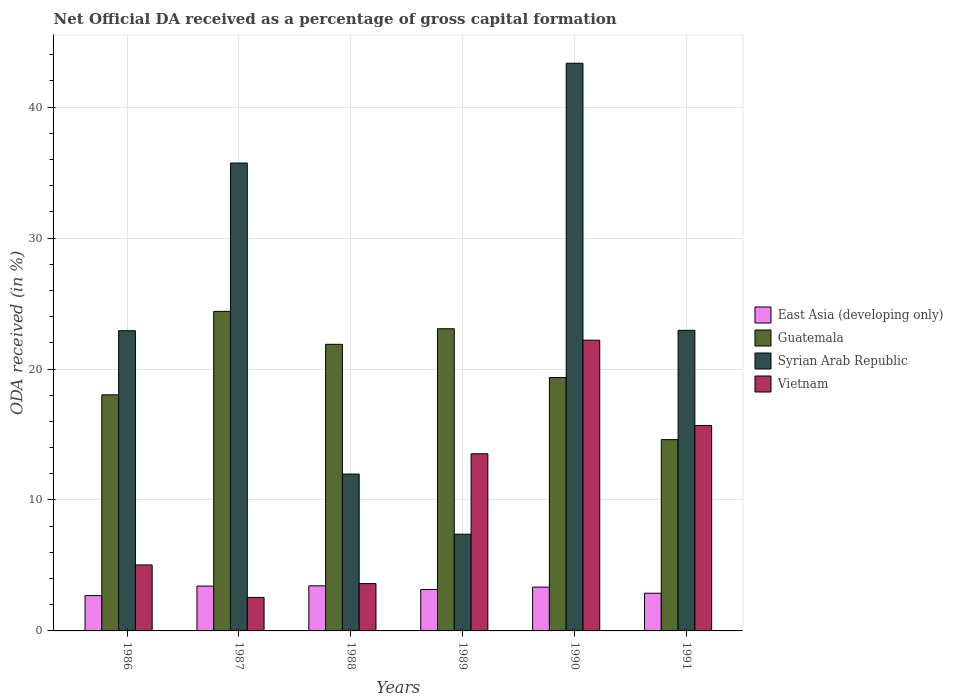How many different coloured bars are there?
Provide a short and direct response. 4. How many bars are there on the 1st tick from the right?
Ensure brevity in your answer.  4. What is the net ODA received in Guatemala in 1986?
Your answer should be compact. 18.03. Across all years, what is the maximum net ODA received in Syrian Arab Republic?
Your answer should be very brief. 43.35. Across all years, what is the minimum net ODA received in Guatemala?
Provide a succinct answer. 14.61. In which year was the net ODA received in Guatemala minimum?
Your response must be concise. 1991. What is the total net ODA received in East Asia (developing only) in the graph?
Offer a very short reply. 18.95. What is the difference between the net ODA received in Syrian Arab Republic in 1986 and that in 1987?
Your answer should be compact. -12.8. What is the difference between the net ODA received in Guatemala in 1986 and the net ODA received in East Asia (developing only) in 1987?
Offer a terse response. 14.61. What is the average net ODA received in Syrian Arab Republic per year?
Your response must be concise. 24.05. In the year 1988, what is the difference between the net ODA received in Vietnam and net ODA received in Syrian Arab Republic?
Keep it short and to the point. -8.36. What is the ratio of the net ODA received in Syrian Arab Republic in 1986 to that in 1990?
Your answer should be very brief. 0.53. Is the difference between the net ODA received in Vietnam in 1989 and 1990 greater than the difference between the net ODA received in Syrian Arab Republic in 1989 and 1990?
Ensure brevity in your answer.  Yes. What is the difference between the highest and the second highest net ODA received in East Asia (developing only)?
Ensure brevity in your answer.  0.02. What is the difference between the highest and the lowest net ODA received in Guatemala?
Keep it short and to the point. 9.79. In how many years, is the net ODA received in Guatemala greater than the average net ODA received in Guatemala taken over all years?
Give a very brief answer. 3. Is the sum of the net ODA received in East Asia (developing only) in 1988 and 1989 greater than the maximum net ODA received in Vietnam across all years?
Your answer should be very brief. No. Is it the case that in every year, the sum of the net ODA received in East Asia (developing only) and net ODA received in Guatemala is greater than the sum of net ODA received in Vietnam and net ODA received in Syrian Arab Republic?
Make the answer very short. No. What does the 1st bar from the left in 1990 represents?
Ensure brevity in your answer.  East Asia (developing only). What does the 4th bar from the right in 1986 represents?
Make the answer very short. East Asia (developing only). Is it the case that in every year, the sum of the net ODA received in Vietnam and net ODA received in Guatemala is greater than the net ODA received in East Asia (developing only)?
Offer a terse response. Yes. How many bars are there?
Make the answer very short. 24. What is the difference between two consecutive major ticks on the Y-axis?
Give a very brief answer. 10. Does the graph contain grids?
Your answer should be compact. Yes. Where does the legend appear in the graph?
Give a very brief answer. Center right. How many legend labels are there?
Your answer should be compact. 4. How are the legend labels stacked?
Provide a short and direct response. Vertical. What is the title of the graph?
Make the answer very short. Net Official DA received as a percentage of gross capital formation. What is the label or title of the Y-axis?
Offer a terse response. ODA received (in %). What is the ODA received (in %) in East Asia (developing only) in 1986?
Offer a terse response. 2.7. What is the ODA received (in %) in Guatemala in 1986?
Your response must be concise. 18.03. What is the ODA received (in %) in Syrian Arab Republic in 1986?
Provide a short and direct response. 22.93. What is the ODA received (in %) of Vietnam in 1986?
Provide a succinct answer. 5.04. What is the ODA received (in %) in East Asia (developing only) in 1987?
Keep it short and to the point. 3.42. What is the ODA received (in %) in Guatemala in 1987?
Keep it short and to the point. 24.4. What is the ODA received (in %) of Syrian Arab Republic in 1987?
Ensure brevity in your answer.  35.73. What is the ODA received (in %) of Vietnam in 1987?
Keep it short and to the point. 2.56. What is the ODA received (in %) in East Asia (developing only) in 1988?
Your answer should be very brief. 3.44. What is the ODA received (in %) in Guatemala in 1988?
Ensure brevity in your answer.  21.89. What is the ODA received (in %) in Syrian Arab Republic in 1988?
Your response must be concise. 11.98. What is the ODA received (in %) of Vietnam in 1988?
Give a very brief answer. 3.61. What is the ODA received (in %) of East Asia (developing only) in 1989?
Your answer should be very brief. 3.16. What is the ODA received (in %) of Guatemala in 1989?
Provide a short and direct response. 23.08. What is the ODA received (in %) in Syrian Arab Republic in 1989?
Provide a succinct answer. 7.39. What is the ODA received (in %) in Vietnam in 1989?
Ensure brevity in your answer.  13.53. What is the ODA received (in %) of East Asia (developing only) in 1990?
Ensure brevity in your answer.  3.35. What is the ODA received (in %) of Guatemala in 1990?
Give a very brief answer. 19.35. What is the ODA received (in %) in Syrian Arab Republic in 1990?
Your answer should be very brief. 43.35. What is the ODA received (in %) of Vietnam in 1990?
Provide a succinct answer. 22.2. What is the ODA received (in %) of East Asia (developing only) in 1991?
Your response must be concise. 2.88. What is the ODA received (in %) in Guatemala in 1991?
Offer a very short reply. 14.61. What is the ODA received (in %) in Syrian Arab Republic in 1991?
Give a very brief answer. 22.95. What is the ODA received (in %) in Vietnam in 1991?
Keep it short and to the point. 15.69. Across all years, what is the maximum ODA received (in %) in East Asia (developing only)?
Make the answer very short. 3.44. Across all years, what is the maximum ODA received (in %) in Guatemala?
Offer a terse response. 24.4. Across all years, what is the maximum ODA received (in %) in Syrian Arab Republic?
Ensure brevity in your answer.  43.35. Across all years, what is the maximum ODA received (in %) of Vietnam?
Your answer should be compact. 22.2. Across all years, what is the minimum ODA received (in %) of East Asia (developing only)?
Provide a succinct answer. 2.7. Across all years, what is the minimum ODA received (in %) in Guatemala?
Offer a terse response. 14.61. Across all years, what is the minimum ODA received (in %) of Syrian Arab Republic?
Make the answer very short. 7.39. Across all years, what is the minimum ODA received (in %) of Vietnam?
Your response must be concise. 2.56. What is the total ODA received (in %) of East Asia (developing only) in the graph?
Ensure brevity in your answer.  18.95. What is the total ODA received (in %) in Guatemala in the graph?
Offer a very short reply. 121.36. What is the total ODA received (in %) in Syrian Arab Republic in the graph?
Your response must be concise. 144.32. What is the total ODA received (in %) of Vietnam in the graph?
Your answer should be compact. 62.63. What is the difference between the ODA received (in %) of East Asia (developing only) in 1986 and that in 1987?
Offer a terse response. -0.73. What is the difference between the ODA received (in %) in Guatemala in 1986 and that in 1987?
Ensure brevity in your answer.  -6.37. What is the difference between the ODA received (in %) of Syrian Arab Republic in 1986 and that in 1987?
Your response must be concise. -12.8. What is the difference between the ODA received (in %) in Vietnam in 1986 and that in 1987?
Ensure brevity in your answer.  2.48. What is the difference between the ODA received (in %) in East Asia (developing only) in 1986 and that in 1988?
Keep it short and to the point. -0.75. What is the difference between the ODA received (in %) of Guatemala in 1986 and that in 1988?
Give a very brief answer. -3.86. What is the difference between the ODA received (in %) in Syrian Arab Republic in 1986 and that in 1988?
Offer a very short reply. 10.95. What is the difference between the ODA received (in %) of Vietnam in 1986 and that in 1988?
Your response must be concise. 1.42. What is the difference between the ODA received (in %) of East Asia (developing only) in 1986 and that in 1989?
Offer a terse response. -0.47. What is the difference between the ODA received (in %) in Guatemala in 1986 and that in 1989?
Make the answer very short. -5.05. What is the difference between the ODA received (in %) in Syrian Arab Republic in 1986 and that in 1989?
Offer a very short reply. 15.54. What is the difference between the ODA received (in %) of Vietnam in 1986 and that in 1989?
Provide a succinct answer. -8.49. What is the difference between the ODA received (in %) in East Asia (developing only) in 1986 and that in 1990?
Your response must be concise. -0.65. What is the difference between the ODA received (in %) in Guatemala in 1986 and that in 1990?
Offer a very short reply. -1.32. What is the difference between the ODA received (in %) of Syrian Arab Republic in 1986 and that in 1990?
Keep it short and to the point. -20.43. What is the difference between the ODA received (in %) in Vietnam in 1986 and that in 1990?
Keep it short and to the point. -17.16. What is the difference between the ODA received (in %) in East Asia (developing only) in 1986 and that in 1991?
Keep it short and to the point. -0.18. What is the difference between the ODA received (in %) in Guatemala in 1986 and that in 1991?
Your response must be concise. 3.42. What is the difference between the ODA received (in %) of Syrian Arab Republic in 1986 and that in 1991?
Your response must be concise. -0.03. What is the difference between the ODA received (in %) of Vietnam in 1986 and that in 1991?
Offer a terse response. -10.65. What is the difference between the ODA received (in %) of East Asia (developing only) in 1987 and that in 1988?
Your response must be concise. -0.02. What is the difference between the ODA received (in %) of Guatemala in 1987 and that in 1988?
Ensure brevity in your answer.  2.52. What is the difference between the ODA received (in %) of Syrian Arab Republic in 1987 and that in 1988?
Your answer should be very brief. 23.75. What is the difference between the ODA received (in %) in Vietnam in 1987 and that in 1988?
Your response must be concise. -1.06. What is the difference between the ODA received (in %) of East Asia (developing only) in 1987 and that in 1989?
Ensure brevity in your answer.  0.26. What is the difference between the ODA received (in %) in Guatemala in 1987 and that in 1989?
Offer a very short reply. 1.33. What is the difference between the ODA received (in %) in Syrian Arab Republic in 1987 and that in 1989?
Your response must be concise. 28.34. What is the difference between the ODA received (in %) in Vietnam in 1987 and that in 1989?
Offer a terse response. -10.97. What is the difference between the ODA received (in %) in East Asia (developing only) in 1987 and that in 1990?
Offer a terse response. 0.08. What is the difference between the ODA received (in %) of Guatemala in 1987 and that in 1990?
Provide a succinct answer. 5.05. What is the difference between the ODA received (in %) in Syrian Arab Republic in 1987 and that in 1990?
Provide a short and direct response. -7.62. What is the difference between the ODA received (in %) in Vietnam in 1987 and that in 1990?
Your response must be concise. -19.64. What is the difference between the ODA received (in %) of East Asia (developing only) in 1987 and that in 1991?
Offer a terse response. 0.54. What is the difference between the ODA received (in %) of Guatemala in 1987 and that in 1991?
Provide a short and direct response. 9.79. What is the difference between the ODA received (in %) of Syrian Arab Republic in 1987 and that in 1991?
Offer a very short reply. 12.78. What is the difference between the ODA received (in %) in Vietnam in 1987 and that in 1991?
Your answer should be very brief. -13.13. What is the difference between the ODA received (in %) of East Asia (developing only) in 1988 and that in 1989?
Ensure brevity in your answer.  0.28. What is the difference between the ODA received (in %) in Guatemala in 1988 and that in 1989?
Offer a terse response. -1.19. What is the difference between the ODA received (in %) in Syrian Arab Republic in 1988 and that in 1989?
Keep it short and to the point. 4.59. What is the difference between the ODA received (in %) in Vietnam in 1988 and that in 1989?
Offer a terse response. -9.91. What is the difference between the ODA received (in %) in East Asia (developing only) in 1988 and that in 1990?
Ensure brevity in your answer.  0.1. What is the difference between the ODA received (in %) of Guatemala in 1988 and that in 1990?
Provide a short and direct response. 2.54. What is the difference between the ODA received (in %) in Syrian Arab Republic in 1988 and that in 1990?
Offer a terse response. -31.37. What is the difference between the ODA received (in %) of Vietnam in 1988 and that in 1990?
Your answer should be very brief. -18.59. What is the difference between the ODA received (in %) of East Asia (developing only) in 1988 and that in 1991?
Give a very brief answer. 0.57. What is the difference between the ODA received (in %) of Guatemala in 1988 and that in 1991?
Your response must be concise. 7.28. What is the difference between the ODA received (in %) in Syrian Arab Republic in 1988 and that in 1991?
Your response must be concise. -10.97. What is the difference between the ODA received (in %) of Vietnam in 1988 and that in 1991?
Offer a very short reply. -12.07. What is the difference between the ODA received (in %) of East Asia (developing only) in 1989 and that in 1990?
Make the answer very short. -0.18. What is the difference between the ODA received (in %) in Guatemala in 1989 and that in 1990?
Ensure brevity in your answer.  3.73. What is the difference between the ODA received (in %) in Syrian Arab Republic in 1989 and that in 1990?
Make the answer very short. -35.96. What is the difference between the ODA received (in %) of Vietnam in 1989 and that in 1990?
Ensure brevity in your answer.  -8.67. What is the difference between the ODA received (in %) in East Asia (developing only) in 1989 and that in 1991?
Offer a terse response. 0.29. What is the difference between the ODA received (in %) of Guatemala in 1989 and that in 1991?
Offer a very short reply. 8.47. What is the difference between the ODA received (in %) in Syrian Arab Republic in 1989 and that in 1991?
Keep it short and to the point. -15.57. What is the difference between the ODA received (in %) of Vietnam in 1989 and that in 1991?
Your answer should be compact. -2.16. What is the difference between the ODA received (in %) of East Asia (developing only) in 1990 and that in 1991?
Provide a short and direct response. 0.47. What is the difference between the ODA received (in %) of Guatemala in 1990 and that in 1991?
Make the answer very short. 4.74. What is the difference between the ODA received (in %) in Syrian Arab Republic in 1990 and that in 1991?
Give a very brief answer. 20.4. What is the difference between the ODA received (in %) of Vietnam in 1990 and that in 1991?
Provide a short and direct response. 6.51. What is the difference between the ODA received (in %) of East Asia (developing only) in 1986 and the ODA received (in %) of Guatemala in 1987?
Offer a terse response. -21.71. What is the difference between the ODA received (in %) of East Asia (developing only) in 1986 and the ODA received (in %) of Syrian Arab Republic in 1987?
Make the answer very short. -33.03. What is the difference between the ODA received (in %) of East Asia (developing only) in 1986 and the ODA received (in %) of Vietnam in 1987?
Provide a short and direct response. 0.14. What is the difference between the ODA received (in %) in Guatemala in 1986 and the ODA received (in %) in Syrian Arab Republic in 1987?
Your answer should be very brief. -17.7. What is the difference between the ODA received (in %) of Guatemala in 1986 and the ODA received (in %) of Vietnam in 1987?
Provide a succinct answer. 15.47. What is the difference between the ODA received (in %) of Syrian Arab Republic in 1986 and the ODA received (in %) of Vietnam in 1987?
Your response must be concise. 20.37. What is the difference between the ODA received (in %) in East Asia (developing only) in 1986 and the ODA received (in %) in Guatemala in 1988?
Ensure brevity in your answer.  -19.19. What is the difference between the ODA received (in %) of East Asia (developing only) in 1986 and the ODA received (in %) of Syrian Arab Republic in 1988?
Your answer should be very brief. -9.28. What is the difference between the ODA received (in %) of East Asia (developing only) in 1986 and the ODA received (in %) of Vietnam in 1988?
Keep it short and to the point. -0.92. What is the difference between the ODA received (in %) of Guatemala in 1986 and the ODA received (in %) of Syrian Arab Republic in 1988?
Offer a terse response. 6.05. What is the difference between the ODA received (in %) of Guatemala in 1986 and the ODA received (in %) of Vietnam in 1988?
Provide a succinct answer. 14.42. What is the difference between the ODA received (in %) of Syrian Arab Republic in 1986 and the ODA received (in %) of Vietnam in 1988?
Give a very brief answer. 19.31. What is the difference between the ODA received (in %) in East Asia (developing only) in 1986 and the ODA received (in %) in Guatemala in 1989?
Ensure brevity in your answer.  -20.38. What is the difference between the ODA received (in %) in East Asia (developing only) in 1986 and the ODA received (in %) in Syrian Arab Republic in 1989?
Ensure brevity in your answer.  -4.69. What is the difference between the ODA received (in %) in East Asia (developing only) in 1986 and the ODA received (in %) in Vietnam in 1989?
Keep it short and to the point. -10.83. What is the difference between the ODA received (in %) of Guatemala in 1986 and the ODA received (in %) of Syrian Arab Republic in 1989?
Your answer should be compact. 10.64. What is the difference between the ODA received (in %) of Guatemala in 1986 and the ODA received (in %) of Vietnam in 1989?
Ensure brevity in your answer.  4.5. What is the difference between the ODA received (in %) in Syrian Arab Republic in 1986 and the ODA received (in %) in Vietnam in 1989?
Provide a short and direct response. 9.4. What is the difference between the ODA received (in %) in East Asia (developing only) in 1986 and the ODA received (in %) in Guatemala in 1990?
Make the answer very short. -16.65. What is the difference between the ODA received (in %) in East Asia (developing only) in 1986 and the ODA received (in %) in Syrian Arab Republic in 1990?
Ensure brevity in your answer.  -40.65. What is the difference between the ODA received (in %) in East Asia (developing only) in 1986 and the ODA received (in %) in Vietnam in 1990?
Keep it short and to the point. -19.5. What is the difference between the ODA received (in %) of Guatemala in 1986 and the ODA received (in %) of Syrian Arab Republic in 1990?
Your answer should be very brief. -25.32. What is the difference between the ODA received (in %) in Guatemala in 1986 and the ODA received (in %) in Vietnam in 1990?
Your answer should be compact. -4.17. What is the difference between the ODA received (in %) of Syrian Arab Republic in 1986 and the ODA received (in %) of Vietnam in 1990?
Your answer should be compact. 0.72. What is the difference between the ODA received (in %) in East Asia (developing only) in 1986 and the ODA received (in %) in Guatemala in 1991?
Provide a succinct answer. -11.91. What is the difference between the ODA received (in %) in East Asia (developing only) in 1986 and the ODA received (in %) in Syrian Arab Republic in 1991?
Your response must be concise. -20.26. What is the difference between the ODA received (in %) of East Asia (developing only) in 1986 and the ODA received (in %) of Vietnam in 1991?
Keep it short and to the point. -12.99. What is the difference between the ODA received (in %) in Guatemala in 1986 and the ODA received (in %) in Syrian Arab Republic in 1991?
Your answer should be compact. -4.92. What is the difference between the ODA received (in %) in Guatemala in 1986 and the ODA received (in %) in Vietnam in 1991?
Ensure brevity in your answer.  2.34. What is the difference between the ODA received (in %) in Syrian Arab Republic in 1986 and the ODA received (in %) in Vietnam in 1991?
Your answer should be very brief. 7.24. What is the difference between the ODA received (in %) of East Asia (developing only) in 1987 and the ODA received (in %) of Guatemala in 1988?
Provide a succinct answer. -18.46. What is the difference between the ODA received (in %) of East Asia (developing only) in 1987 and the ODA received (in %) of Syrian Arab Republic in 1988?
Give a very brief answer. -8.56. What is the difference between the ODA received (in %) of East Asia (developing only) in 1987 and the ODA received (in %) of Vietnam in 1988?
Give a very brief answer. -0.19. What is the difference between the ODA received (in %) in Guatemala in 1987 and the ODA received (in %) in Syrian Arab Republic in 1988?
Provide a succinct answer. 12.43. What is the difference between the ODA received (in %) of Guatemala in 1987 and the ODA received (in %) of Vietnam in 1988?
Provide a short and direct response. 20.79. What is the difference between the ODA received (in %) in Syrian Arab Republic in 1987 and the ODA received (in %) in Vietnam in 1988?
Give a very brief answer. 32.12. What is the difference between the ODA received (in %) in East Asia (developing only) in 1987 and the ODA received (in %) in Guatemala in 1989?
Your response must be concise. -19.65. What is the difference between the ODA received (in %) in East Asia (developing only) in 1987 and the ODA received (in %) in Syrian Arab Republic in 1989?
Ensure brevity in your answer.  -3.96. What is the difference between the ODA received (in %) in East Asia (developing only) in 1987 and the ODA received (in %) in Vietnam in 1989?
Your response must be concise. -10.1. What is the difference between the ODA received (in %) of Guatemala in 1987 and the ODA received (in %) of Syrian Arab Republic in 1989?
Offer a terse response. 17.02. What is the difference between the ODA received (in %) in Guatemala in 1987 and the ODA received (in %) in Vietnam in 1989?
Make the answer very short. 10.88. What is the difference between the ODA received (in %) of Syrian Arab Republic in 1987 and the ODA received (in %) of Vietnam in 1989?
Keep it short and to the point. 22.2. What is the difference between the ODA received (in %) of East Asia (developing only) in 1987 and the ODA received (in %) of Guatemala in 1990?
Give a very brief answer. -15.93. What is the difference between the ODA received (in %) of East Asia (developing only) in 1987 and the ODA received (in %) of Syrian Arab Republic in 1990?
Ensure brevity in your answer.  -39.93. What is the difference between the ODA received (in %) of East Asia (developing only) in 1987 and the ODA received (in %) of Vietnam in 1990?
Make the answer very short. -18.78. What is the difference between the ODA received (in %) in Guatemala in 1987 and the ODA received (in %) in Syrian Arab Republic in 1990?
Your answer should be very brief. -18.95. What is the difference between the ODA received (in %) in Guatemala in 1987 and the ODA received (in %) in Vietnam in 1990?
Keep it short and to the point. 2.2. What is the difference between the ODA received (in %) of Syrian Arab Republic in 1987 and the ODA received (in %) of Vietnam in 1990?
Make the answer very short. 13.53. What is the difference between the ODA received (in %) of East Asia (developing only) in 1987 and the ODA received (in %) of Guatemala in 1991?
Your response must be concise. -11.19. What is the difference between the ODA received (in %) of East Asia (developing only) in 1987 and the ODA received (in %) of Syrian Arab Republic in 1991?
Give a very brief answer. -19.53. What is the difference between the ODA received (in %) in East Asia (developing only) in 1987 and the ODA received (in %) in Vietnam in 1991?
Your response must be concise. -12.27. What is the difference between the ODA received (in %) in Guatemala in 1987 and the ODA received (in %) in Syrian Arab Republic in 1991?
Keep it short and to the point. 1.45. What is the difference between the ODA received (in %) of Guatemala in 1987 and the ODA received (in %) of Vietnam in 1991?
Make the answer very short. 8.71. What is the difference between the ODA received (in %) of Syrian Arab Republic in 1987 and the ODA received (in %) of Vietnam in 1991?
Offer a very short reply. 20.04. What is the difference between the ODA received (in %) in East Asia (developing only) in 1988 and the ODA received (in %) in Guatemala in 1989?
Give a very brief answer. -19.63. What is the difference between the ODA received (in %) in East Asia (developing only) in 1988 and the ODA received (in %) in Syrian Arab Republic in 1989?
Your answer should be very brief. -3.94. What is the difference between the ODA received (in %) of East Asia (developing only) in 1988 and the ODA received (in %) of Vietnam in 1989?
Offer a terse response. -10.08. What is the difference between the ODA received (in %) in Guatemala in 1988 and the ODA received (in %) in Syrian Arab Republic in 1989?
Your answer should be very brief. 14.5. What is the difference between the ODA received (in %) in Guatemala in 1988 and the ODA received (in %) in Vietnam in 1989?
Give a very brief answer. 8.36. What is the difference between the ODA received (in %) in Syrian Arab Republic in 1988 and the ODA received (in %) in Vietnam in 1989?
Provide a succinct answer. -1.55. What is the difference between the ODA received (in %) of East Asia (developing only) in 1988 and the ODA received (in %) of Guatemala in 1990?
Give a very brief answer. -15.91. What is the difference between the ODA received (in %) of East Asia (developing only) in 1988 and the ODA received (in %) of Syrian Arab Republic in 1990?
Give a very brief answer. -39.91. What is the difference between the ODA received (in %) in East Asia (developing only) in 1988 and the ODA received (in %) in Vietnam in 1990?
Make the answer very short. -18.76. What is the difference between the ODA received (in %) in Guatemala in 1988 and the ODA received (in %) in Syrian Arab Republic in 1990?
Keep it short and to the point. -21.46. What is the difference between the ODA received (in %) of Guatemala in 1988 and the ODA received (in %) of Vietnam in 1990?
Keep it short and to the point. -0.31. What is the difference between the ODA received (in %) in Syrian Arab Republic in 1988 and the ODA received (in %) in Vietnam in 1990?
Your response must be concise. -10.22. What is the difference between the ODA received (in %) of East Asia (developing only) in 1988 and the ODA received (in %) of Guatemala in 1991?
Make the answer very short. -11.16. What is the difference between the ODA received (in %) of East Asia (developing only) in 1988 and the ODA received (in %) of Syrian Arab Republic in 1991?
Provide a short and direct response. -19.51. What is the difference between the ODA received (in %) in East Asia (developing only) in 1988 and the ODA received (in %) in Vietnam in 1991?
Your response must be concise. -12.25. What is the difference between the ODA received (in %) in Guatemala in 1988 and the ODA received (in %) in Syrian Arab Republic in 1991?
Provide a short and direct response. -1.06. What is the difference between the ODA received (in %) of Guatemala in 1988 and the ODA received (in %) of Vietnam in 1991?
Make the answer very short. 6.2. What is the difference between the ODA received (in %) of Syrian Arab Republic in 1988 and the ODA received (in %) of Vietnam in 1991?
Your answer should be compact. -3.71. What is the difference between the ODA received (in %) in East Asia (developing only) in 1989 and the ODA received (in %) in Guatemala in 1990?
Make the answer very short. -16.19. What is the difference between the ODA received (in %) in East Asia (developing only) in 1989 and the ODA received (in %) in Syrian Arab Republic in 1990?
Provide a succinct answer. -40.19. What is the difference between the ODA received (in %) of East Asia (developing only) in 1989 and the ODA received (in %) of Vietnam in 1990?
Make the answer very short. -19.04. What is the difference between the ODA received (in %) in Guatemala in 1989 and the ODA received (in %) in Syrian Arab Republic in 1990?
Give a very brief answer. -20.27. What is the difference between the ODA received (in %) of Guatemala in 1989 and the ODA received (in %) of Vietnam in 1990?
Offer a very short reply. 0.87. What is the difference between the ODA received (in %) of Syrian Arab Republic in 1989 and the ODA received (in %) of Vietnam in 1990?
Keep it short and to the point. -14.81. What is the difference between the ODA received (in %) in East Asia (developing only) in 1989 and the ODA received (in %) in Guatemala in 1991?
Your answer should be compact. -11.44. What is the difference between the ODA received (in %) in East Asia (developing only) in 1989 and the ODA received (in %) in Syrian Arab Republic in 1991?
Provide a succinct answer. -19.79. What is the difference between the ODA received (in %) in East Asia (developing only) in 1989 and the ODA received (in %) in Vietnam in 1991?
Provide a short and direct response. -12.53. What is the difference between the ODA received (in %) of Guatemala in 1989 and the ODA received (in %) of Syrian Arab Republic in 1991?
Ensure brevity in your answer.  0.12. What is the difference between the ODA received (in %) in Guatemala in 1989 and the ODA received (in %) in Vietnam in 1991?
Keep it short and to the point. 7.39. What is the difference between the ODA received (in %) of Syrian Arab Republic in 1989 and the ODA received (in %) of Vietnam in 1991?
Provide a short and direct response. -8.3. What is the difference between the ODA received (in %) of East Asia (developing only) in 1990 and the ODA received (in %) of Guatemala in 1991?
Provide a short and direct response. -11.26. What is the difference between the ODA received (in %) of East Asia (developing only) in 1990 and the ODA received (in %) of Syrian Arab Republic in 1991?
Provide a succinct answer. -19.61. What is the difference between the ODA received (in %) of East Asia (developing only) in 1990 and the ODA received (in %) of Vietnam in 1991?
Make the answer very short. -12.34. What is the difference between the ODA received (in %) in Guatemala in 1990 and the ODA received (in %) in Syrian Arab Republic in 1991?
Give a very brief answer. -3.6. What is the difference between the ODA received (in %) of Guatemala in 1990 and the ODA received (in %) of Vietnam in 1991?
Make the answer very short. 3.66. What is the difference between the ODA received (in %) of Syrian Arab Republic in 1990 and the ODA received (in %) of Vietnam in 1991?
Your answer should be compact. 27.66. What is the average ODA received (in %) in East Asia (developing only) per year?
Offer a very short reply. 3.16. What is the average ODA received (in %) of Guatemala per year?
Your response must be concise. 20.23. What is the average ODA received (in %) of Syrian Arab Republic per year?
Keep it short and to the point. 24.05. What is the average ODA received (in %) in Vietnam per year?
Provide a short and direct response. 10.44. In the year 1986, what is the difference between the ODA received (in %) in East Asia (developing only) and ODA received (in %) in Guatemala?
Provide a short and direct response. -15.33. In the year 1986, what is the difference between the ODA received (in %) of East Asia (developing only) and ODA received (in %) of Syrian Arab Republic?
Make the answer very short. -20.23. In the year 1986, what is the difference between the ODA received (in %) in East Asia (developing only) and ODA received (in %) in Vietnam?
Your answer should be very brief. -2.34. In the year 1986, what is the difference between the ODA received (in %) of Guatemala and ODA received (in %) of Syrian Arab Republic?
Your answer should be very brief. -4.9. In the year 1986, what is the difference between the ODA received (in %) of Guatemala and ODA received (in %) of Vietnam?
Ensure brevity in your answer.  12.99. In the year 1986, what is the difference between the ODA received (in %) of Syrian Arab Republic and ODA received (in %) of Vietnam?
Ensure brevity in your answer.  17.89. In the year 1987, what is the difference between the ODA received (in %) in East Asia (developing only) and ODA received (in %) in Guatemala?
Offer a very short reply. -20.98. In the year 1987, what is the difference between the ODA received (in %) of East Asia (developing only) and ODA received (in %) of Syrian Arab Republic?
Offer a terse response. -32.31. In the year 1987, what is the difference between the ODA received (in %) of East Asia (developing only) and ODA received (in %) of Vietnam?
Provide a succinct answer. 0.86. In the year 1987, what is the difference between the ODA received (in %) in Guatemala and ODA received (in %) in Syrian Arab Republic?
Give a very brief answer. -11.33. In the year 1987, what is the difference between the ODA received (in %) in Guatemala and ODA received (in %) in Vietnam?
Offer a terse response. 21.84. In the year 1987, what is the difference between the ODA received (in %) of Syrian Arab Republic and ODA received (in %) of Vietnam?
Ensure brevity in your answer.  33.17. In the year 1988, what is the difference between the ODA received (in %) in East Asia (developing only) and ODA received (in %) in Guatemala?
Your answer should be compact. -18.44. In the year 1988, what is the difference between the ODA received (in %) in East Asia (developing only) and ODA received (in %) in Syrian Arab Republic?
Give a very brief answer. -8.53. In the year 1988, what is the difference between the ODA received (in %) in East Asia (developing only) and ODA received (in %) in Vietnam?
Provide a short and direct response. -0.17. In the year 1988, what is the difference between the ODA received (in %) in Guatemala and ODA received (in %) in Syrian Arab Republic?
Your answer should be very brief. 9.91. In the year 1988, what is the difference between the ODA received (in %) in Guatemala and ODA received (in %) in Vietnam?
Your answer should be compact. 18.27. In the year 1988, what is the difference between the ODA received (in %) of Syrian Arab Republic and ODA received (in %) of Vietnam?
Give a very brief answer. 8.36. In the year 1989, what is the difference between the ODA received (in %) in East Asia (developing only) and ODA received (in %) in Guatemala?
Give a very brief answer. -19.91. In the year 1989, what is the difference between the ODA received (in %) in East Asia (developing only) and ODA received (in %) in Syrian Arab Republic?
Make the answer very short. -4.22. In the year 1989, what is the difference between the ODA received (in %) of East Asia (developing only) and ODA received (in %) of Vietnam?
Ensure brevity in your answer.  -10.36. In the year 1989, what is the difference between the ODA received (in %) in Guatemala and ODA received (in %) in Syrian Arab Republic?
Make the answer very short. 15.69. In the year 1989, what is the difference between the ODA received (in %) in Guatemala and ODA received (in %) in Vietnam?
Offer a terse response. 9.55. In the year 1989, what is the difference between the ODA received (in %) in Syrian Arab Republic and ODA received (in %) in Vietnam?
Keep it short and to the point. -6.14. In the year 1990, what is the difference between the ODA received (in %) in East Asia (developing only) and ODA received (in %) in Guatemala?
Make the answer very short. -16. In the year 1990, what is the difference between the ODA received (in %) of East Asia (developing only) and ODA received (in %) of Syrian Arab Republic?
Give a very brief answer. -40. In the year 1990, what is the difference between the ODA received (in %) of East Asia (developing only) and ODA received (in %) of Vietnam?
Ensure brevity in your answer.  -18.85. In the year 1990, what is the difference between the ODA received (in %) of Guatemala and ODA received (in %) of Syrian Arab Republic?
Give a very brief answer. -24. In the year 1990, what is the difference between the ODA received (in %) of Guatemala and ODA received (in %) of Vietnam?
Your answer should be compact. -2.85. In the year 1990, what is the difference between the ODA received (in %) of Syrian Arab Republic and ODA received (in %) of Vietnam?
Ensure brevity in your answer.  21.15. In the year 1991, what is the difference between the ODA received (in %) of East Asia (developing only) and ODA received (in %) of Guatemala?
Make the answer very short. -11.73. In the year 1991, what is the difference between the ODA received (in %) in East Asia (developing only) and ODA received (in %) in Syrian Arab Republic?
Give a very brief answer. -20.07. In the year 1991, what is the difference between the ODA received (in %) of East Asia (developing only) and ODA received (in %) of Vietnam?
Make the answer very short. -12.81. In the year 1991, what is the difference between the ODA received (in %) of Guatemala and ODA received (in %) of Syrian Arab Republic?
Offer a terse response. -8.34. In the year 1991, what is the difference between the ODA received (in %) in Guatemala and ODA received (in %) in Vietnam?
Offer a very short reply. -1.08. In the year 1991, what is the difference between the ODA received (in %) of Syrian Arab Republic and ODA received (in %) of Vietnam?
Your answer should be compact. 7.26. What is the ratio of the ODA received (in %) of East Asia (developing only) in 1986 to that in 1987?
Your response must be concise. 0.79. What is the ratio of the ODA received (in %) of Guatemala in 1986 to that in 1987?
Give a very brief answer. 0.74. What is the ratio of the ODA received (in %) in Syrian Arab Republic in 1986 to that in 1987?
Provide a succinct answer. 0.64. What is the ratio of the ODA received (in %) of Vietnam in 1986 to that in 1987?
Your answer should be very brief. 1.97. What is the ratio of the ODA received (in %) in East Asia (developing only) in 1986 to that in 1988?
Your answer should be very brief. 0.78. What is the ratio of the ODA received (in %) of Guatemala in 1986 to that in 1988?
Ensure brevity in your answer.  0.82. What is the ratio of the ODA received (in %) of Syrian Arab Republic in 1986 to that in 1988?
Offer a terse response. 1.91. What is the ratio of the ODA received (in %) of Vietnam in 1986 to that in 1988?
Your answer should be very brief. 1.39. What is the ratio of the ODA received (in %) in East Asia (developing only) in 1986 to that in 1989?
Your answer should be very brief. 0.85. What is the ratio of the ODA received (in %) in Guatemala in 1986 to that in 1989?
Offer a very short reply. 0.78. What is the ratio of the ODA received (in %) in Syrian Arab Republic in 1986 to that in 1989?
Your response must be concise. 3.1. What is the ratio of the ODA received (in %) of Vietnam in 1986 to that in 1989?
Your answer should be very brief. 0.37. What is the ratio of the ODA received (in %) in East Asia (developing only) in 1986 to that in 1990?
Keep it short and to the point. 0.81. What is the ratio of the ODA received (in %) in Guatemala in 1986 to that in 1990?
Provide a short and direct response. 0.93. What is the ratio of the ODA received (in %) of Syrian Arab Republic in 1986 to that in 1990?
Provide a short and direct response. 0.53. What is the ratio of the ODA received (in %) of Vietnam in 1986 to that in 1990?
Offer a very short reply. 0.23. What is the ratio of the ODA received (in %) of East Asia (developing only) in 1986 to that in 1991?
Provide a succinct answer. 0.94. What is the ratio of the ODA received (in %) in Guatemala in 1986 to that in 1991?
Provide a succinct answer. 1.23. What is the ratio of the ODA received (in %) of Syrian Arab Republic in 1986 to that in 1991?
Offer a terse response. 1. What is the ratio of the ODA received (in %) of Vietnam in 1986 to that in 1991?
Make the answer very short. 0.32. What is the ratio of the ODA received (in %) in Guatemala in 1987 to that in 1988?
Give a very brief answer. 1.11. What is the ratio of the ODA received (in %) in Syrian Arab Republic in 1987 to that in 1988?
Provide a short and direct response. 2.98. What is the ratio of the ODA received (in %) of Vietnam in 1987 to that in 1988?
Give a very brief answer. 0.71. What is the ratio of the ODA received (in %) in East Asia (developing only) in 1987 to that in 1989?
Offer a very short reply. 1.08. What is the ratio of the ODA received (in %) of Guatemala in 1987 to that in 1989?
Make the answer very short. 1.06. What is the ratio of the ODA received (in %) of Syrian Arab Republic in 1987 to that in 1989?
Give a very brief answer. 4.84. What is the ratio of the ODA received (in %) of Vietnam in 1987 to that in 1989?
Your answer should be compact. 0.19. What is the ratio of the ODA received (in %) in East Asia (developing only) in 1987 to that in 1990?
Your response must be concise. 1.02. What is the ratio of the ODA received (in %) in Guatemala in 1987 to that in 1990?
Offer a very short reply. 1.26. What is the ratio of the ODA received (in %) of Syrian Arab Republic in 1987 to that in 1990?
Give a very brief answer. 0.82. What is the ratio of the ODA received (in %) of Vietnam in 1987 to that in 1990?
Offer a terse response. 0.12. What is the ratio of the ODA received (in %) in East Asia (developing only) in 1987 to that in 1991?
Offer a terse response. 1.19. What is the ratio of the ODA received (in %) of Guatemala in 1987 to that in 1991?
Provide a succinct answer. 1.67. What is the ratio of the ODA received (in %) of Syrian Arab Republic in 1987 to that in 1991?
Make the answer very short. 1.56. What is the ratio of the ODA received (in %) in Vietnam in 1987 to that in 1991?
Give a very brief answer. 0.16. What is the ratio of the ODA received (in %) in East Asia (developing only) in 1988 to that in 1989?
Give a very brief answer. 1.09. What is the ratio of the ODA received (in %) in Guatemala in 1988 to that in 1989?
Keep it short and to the point. 0.95. What is the ratio of the ODA received (in %) of Syrian Arab Republic in 1988 to that in 1989?
Make the answer very short. 1.62. What is the ratio of the ODA received (in %) in Vietnam in 1988 to that in 1989?
Your response must be concise. 0.27. What is the ratio of the ODA received (in %) in Guatemala in 1988 to that in 1990?
Provide a short and direct response. 1.13. What is the ratio of the ODA received (in %) in Syrian Arab Republic in 1988 to that in 1990?
Your answer should be compact. 0.28. What is the ratio of the ODA received (in %) in Vietnam in 1988 to that in 1990?
Give a very brief answer. 0.16. What is the ratio of the ODA received (in %) of East Asia (developing only) in 1988 to that in 1991?
Provide a short and direct response. 1.2. What is the ratio of the ODA received (in %) of Guatemala in 1988 to that in 1991?
Keep it short and to the point. 1.5. What is the ratio of the ODA received (in %) of Syrian Arab Republic in 1988 to that in 1991?
Ensure brevity in your answer.  0.52. What is the ratio of the ODA received (in %) in Vietnam in 1988 to that in 1991?
Make the answer very short. 0.23. What is the ratio of the ODA received (in %) of East Asia (developing only) in 1989 to that in 1990?
Provide a short and direct response. 0.95. What is the ratio of the ODA received (in %) in Guatemala in 1989 to that in 1990?
Provide a succinct answer. 1.19. What is the ratio of the ODA received (in %) in Syrian Arab Republic in 1989 to that in 1990?
Offer a very short reply. 0.17. What is the ratio of the ODA received (in %) in Vietnam in 1989 to that in 1990?
Give a very brief answer. 0.61. What is the ratio of the ODA received (in %) in East Asia (developing only) in 1989 to that in 1991?
Your response must be concise. 1.1. What is the ratio of the ODA received (in %) of Guatemala in 1989 to that in 1991?
Your answer should be very brief. 1.58. What is the ratio of the ODA received (in %) of Syrian Arab Republic in 1989 to that in 1991?
Provide a succinct answer. 0.32. What is the ratio of the ODA received (in %) of Vietnam in 1989 to that in 1991?
Your response must be concise. 0.86. What is the ratio of the ODA received (in %) in East Asia (developing only) in 1990 to that in 1991?
Provide a short and direct response. 1.16. What is the ratio of the ODA received (in %) of Guatemala in 1990 to that in 1991?
Keep it short and to the point. 1.32. What is the ratio of the ODA received (in %) of Syrian Arab Republic in 1990 to that in 1991?
Make the answer very short. 1.89. What is the ratio of the ODA received (in %) in Vietnam in 1990 to that in 1991?
Offer a very short reply. 1.42. What is the difference between the highest and the second highest ODA received (in %) of East Asia (developing only)?
Keep it short and to the point. 0.02. What is the difference between the highest and the second highest ODA received (in %) in Guatemala?
Provide a short and direct response. 1.33. What is the difference between the highest and the second highest ODA received (in %) in Syrian Arab Republic?
Ensure brevity in your answer.  7.62. What is the difference between the highest and the second highest ODA received (in %) of Vietnam?
Your answer should be very brief. 6.51. What is the difference between the highest and the lowest ODA received (in %) in East Asia (developing only)?
Offer a very short reply. 0.75. What is the difference between the highest and the lowest ODA received (in %) in Guatemala?
Make the answer very short. 9.79. What is the difference between the highest and the lowest ODA received (in %) of Syrian Arab Republic?
Your response must be concise. 35.96. What is the difference between the highest and the lowest ODA received (in %) in Vietnam?
Ensure brevity in your answer.  19.64. 